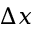Convert formula to latex. <formula><loc_0><loc_0><loc_500><loc_500>\Delta x</formula> 